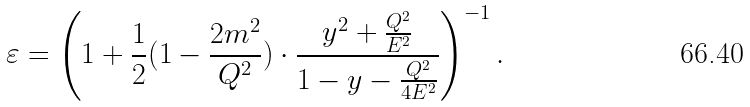<formula> <loc_0><loc_0><loc_500><loc_500>\varepsilon = \left ( 1 + \frac { 1 } { 2 } ( 1 - \frac { 2 m ^ { 2 } } { Q ^ { 2 } } ) \cdot \frac { y ^ { 2 } + \frac { Q ^ { 2 } } { E ^ { 2 } } } { 1 - y - \frac { Q ^ { 2 } } { 4 E ^ { 2 } } } \right ) ^ { - 1 } .</formula> 